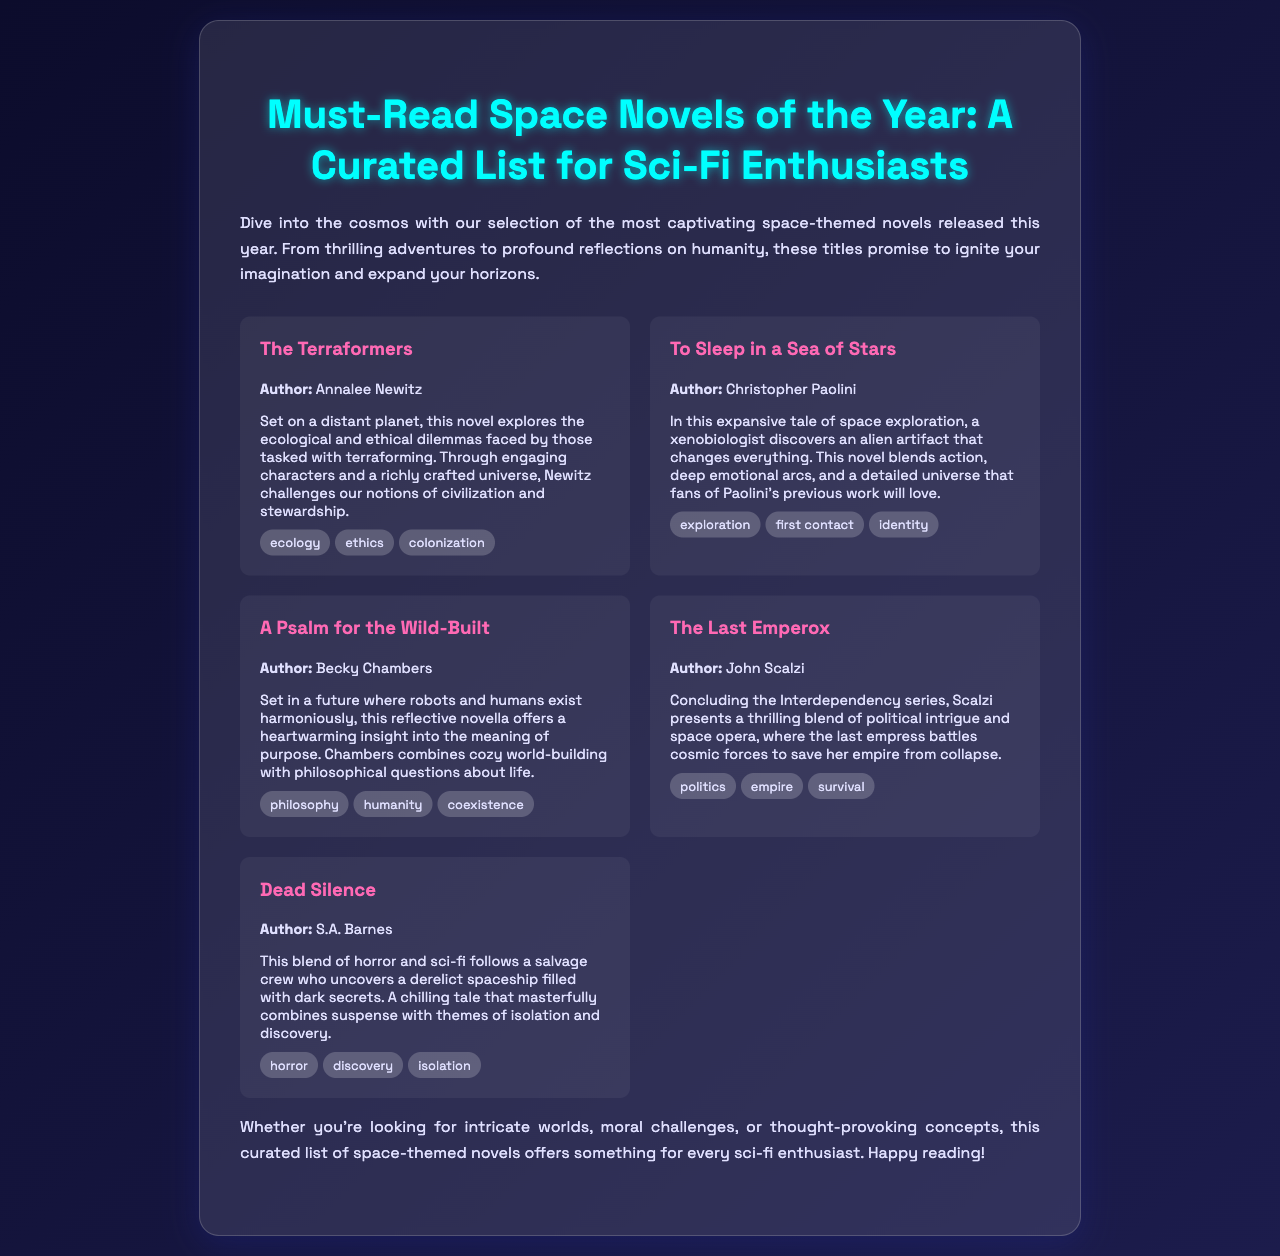what is the title of the brochure? The title of the brochure is prominently displayed in a large font at the top of the document.
Answer: Must-Read Space Novels of the Year: A Curated List for Sci-Fi Enthusiasts who is the author of "The Terraformers"? The brochure provides specific author information for each novel listed.
Answer: Annalee Newitz which theme is associated with "A Psalm for the Wild-Built"? Each novel features several themes listed within the description section.
Answer: philosophy how many novels are included in the brochure? The total number of novels can be counted based on the individual entries presented in the document.
Answer: 5 what genre does "Dead Silence" combine with sci-fi? The document lists genres for each novel, highlighting their unique aspects.
Answer: horror which author has previously written other works that appeal to fans of "To Sleep in a Sea of Stars"? The text mentions this author's previous works, implying a connection to the current novel.
Answer: Christopher Paolini what is the primary setting of "The Last Emperox"? The setting is described in the context of the novel's plot and themes.
Answer: Interdependency series what is the main conflict in "Dead Silence"? The brochure outlines the central conflict or premise of each novel.
Answer: uncovering a derelict spaceship filled with dark secrets 